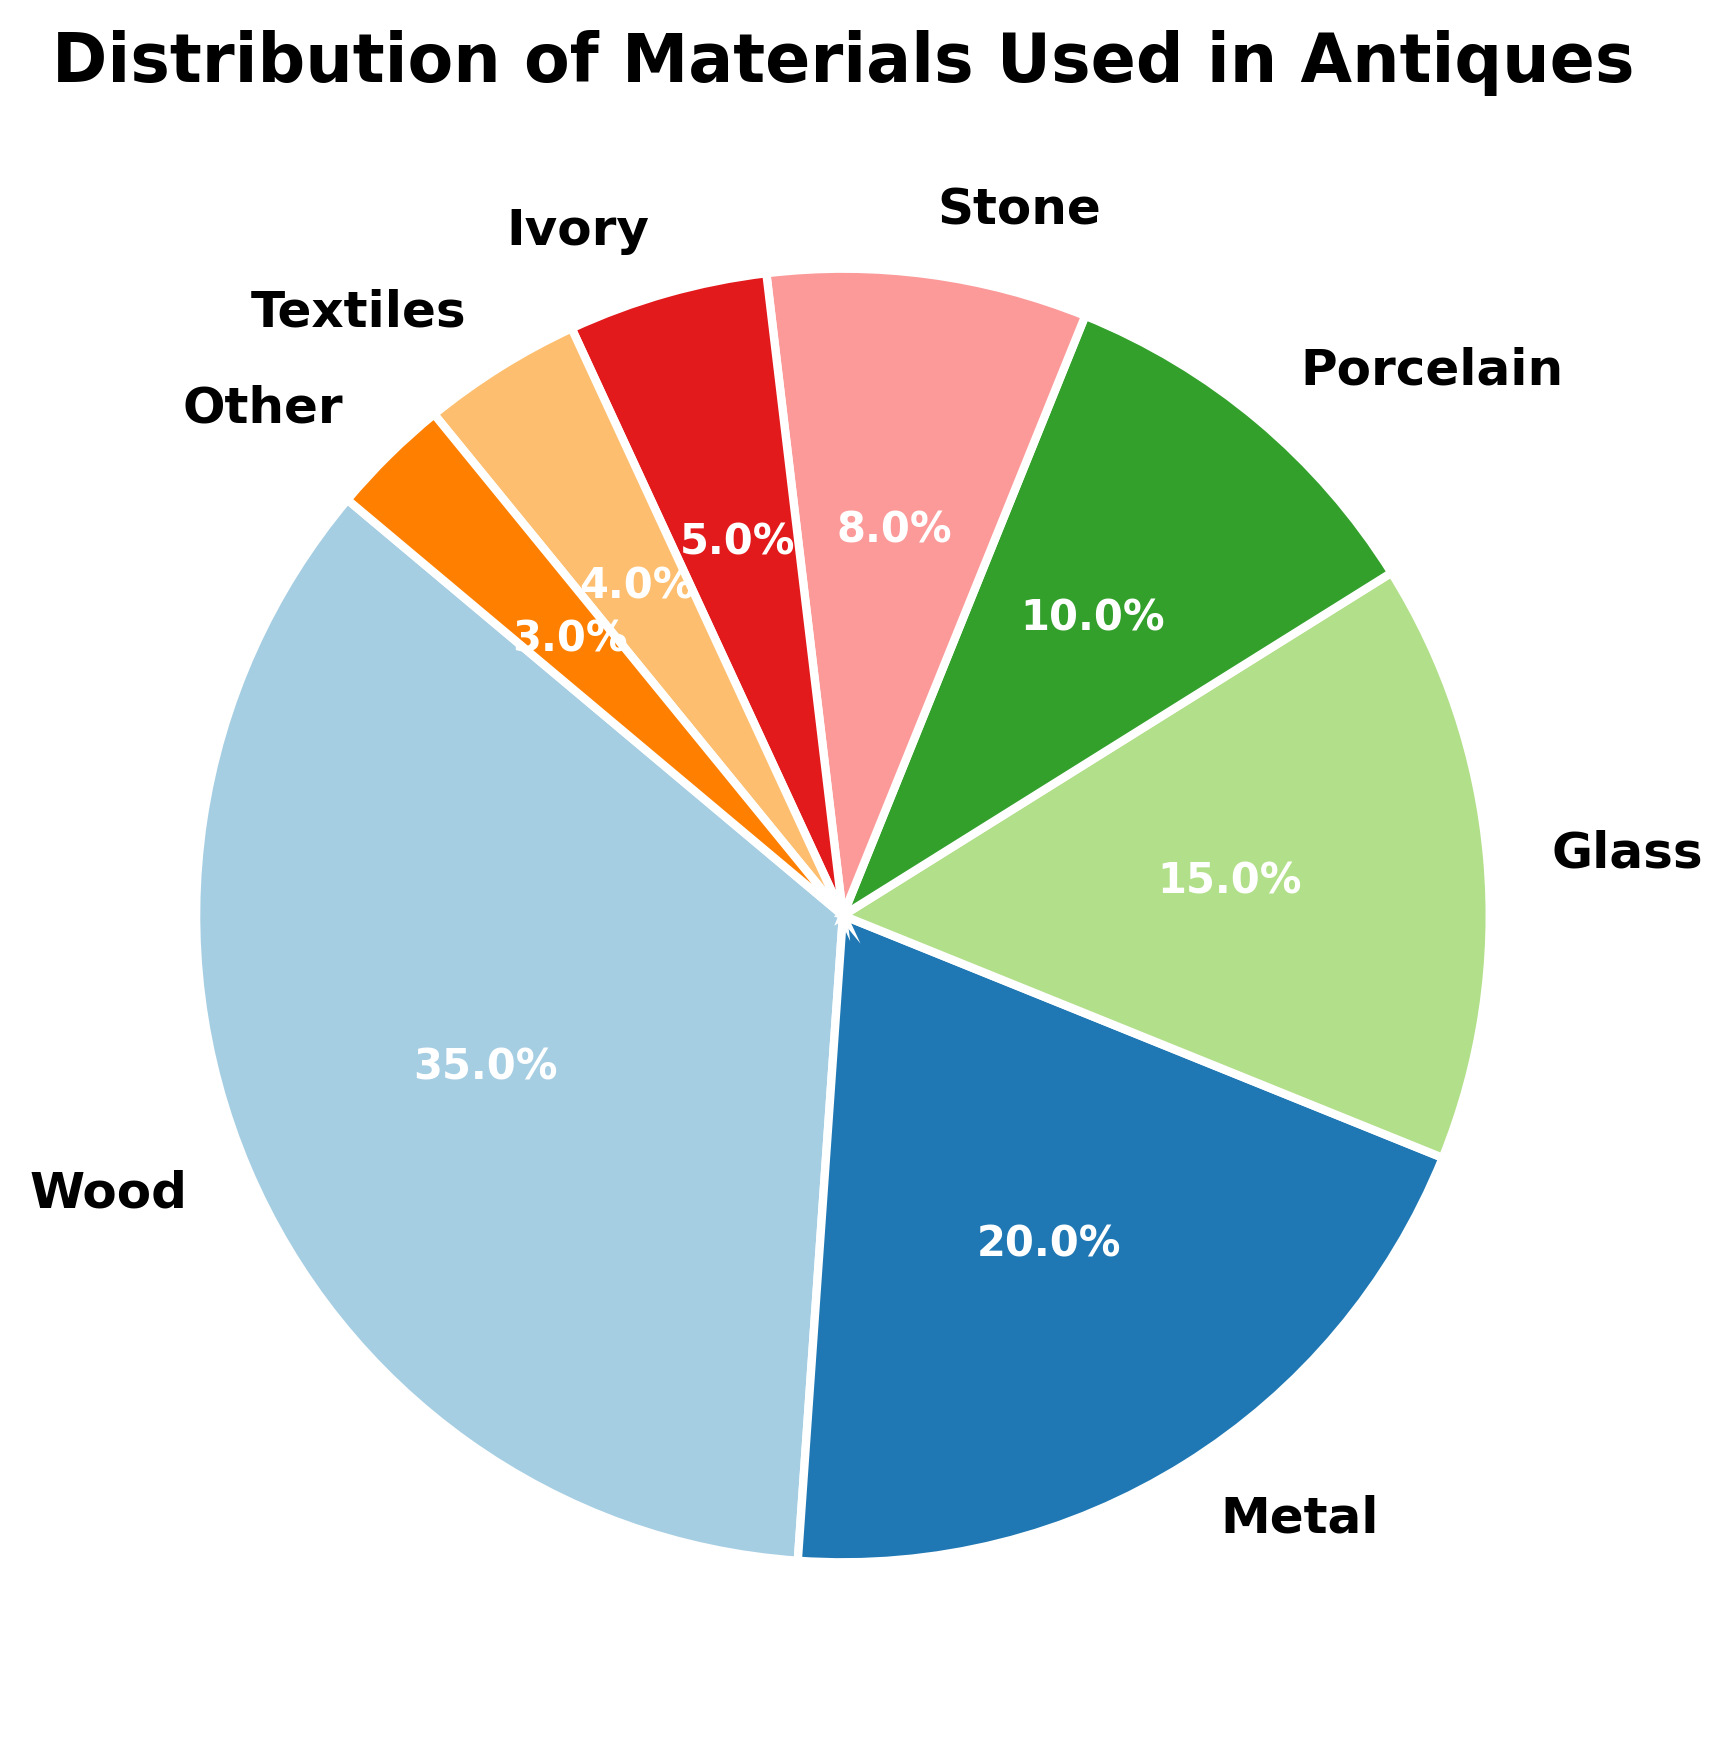Which material constitutes the largest portion of the antiques? The figure shows a pie chart with sections representing different materials. The largest section corresponds to Wood.
Answer: Wood What is the combined percentage of Metal and Glass in antiques? From the figure, Metal constitutes 20% and Glass constitutes 15%. Adding these percentages gives 20% + 15% = 35%.
Answer: 35% Which materials together make up at least half of the antiques? Adding the percentages from the chart, Wood is 35% and Metal is 20%. Together they make 35% + 20% = 55%, which is more than half.
Answer: Wood and Metal How much larger in percentage is Wood compared to Porcelain? From the figure, Wood is 35% and Porcelain is 10%. The difference is 35% - 10% = 25%.
Answer: 25% Which material represents the smallest percentage in the chart? The smallest section of the pie chart corresponds to Other, which is shown as 3%.
Answer: Other Are there more antique items made of Porcelain or Stone? According to the chart, Porcelain makes up 10% while Stone makes up 8%, so there are more antiques made of Porcelain.
Answer: Porcelain What percentage of antiques are made of Textiles and Ivory combined? From the chart, Textiles are 4% and Ivory is 5%. Summing these gives 4% + 5% = 9%.
Answer: 9% Compare the combined percentage of Glass and Porcelain with Wood. Which one is higher, and by how much? Glass is 15% and Porcelain is 10%, adding to 25%. Wood is 35%. The difference is 35% - 25% = 10%. Therefore, Wood is higher by 10%.
Answer: Wood by 10% If we combine Stone, Ivory, and Textiles, what percentage of the total do they represent? Stone is 8%, Ivory is 5%, and Textiles are 4%. Summing these gives 8% + 5% + 4% = 17%.
Answer: 17% 